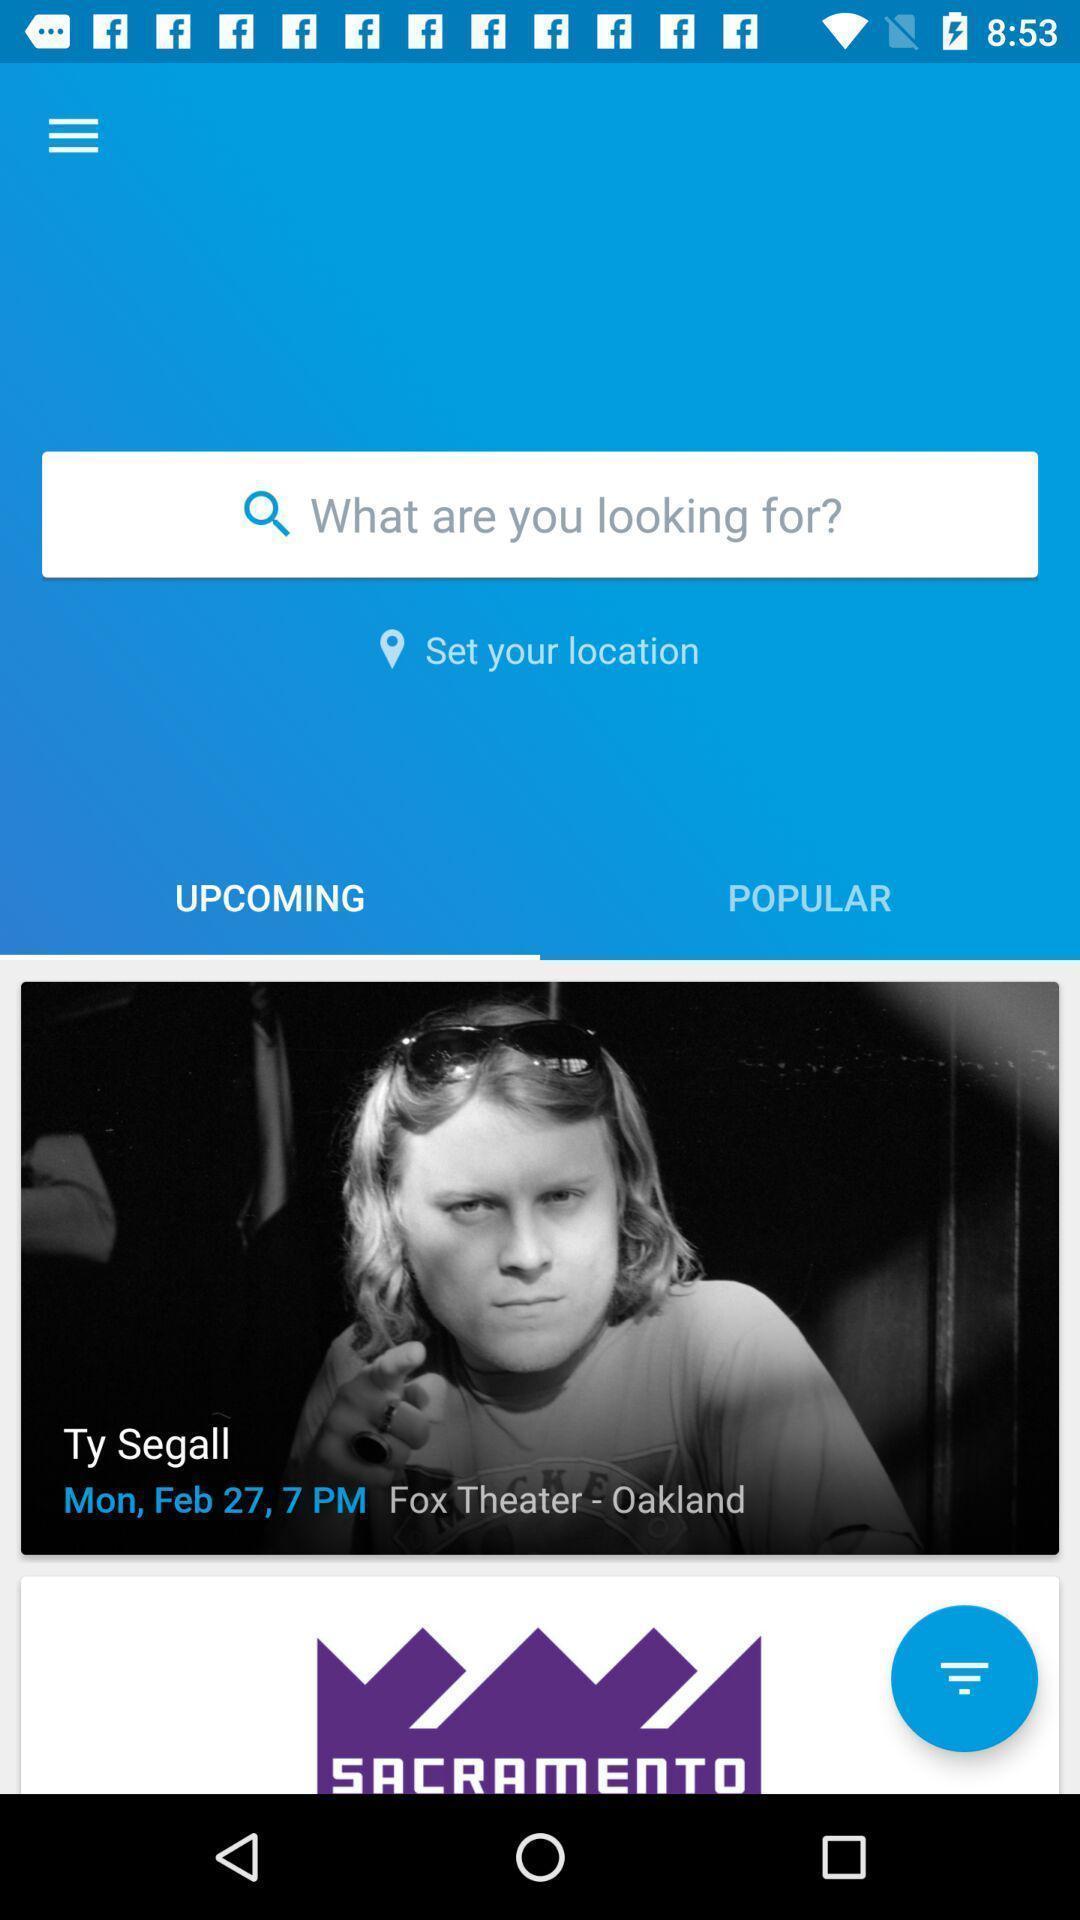Describe the visual elements of this screenshot. Search page in a ticket service app. 